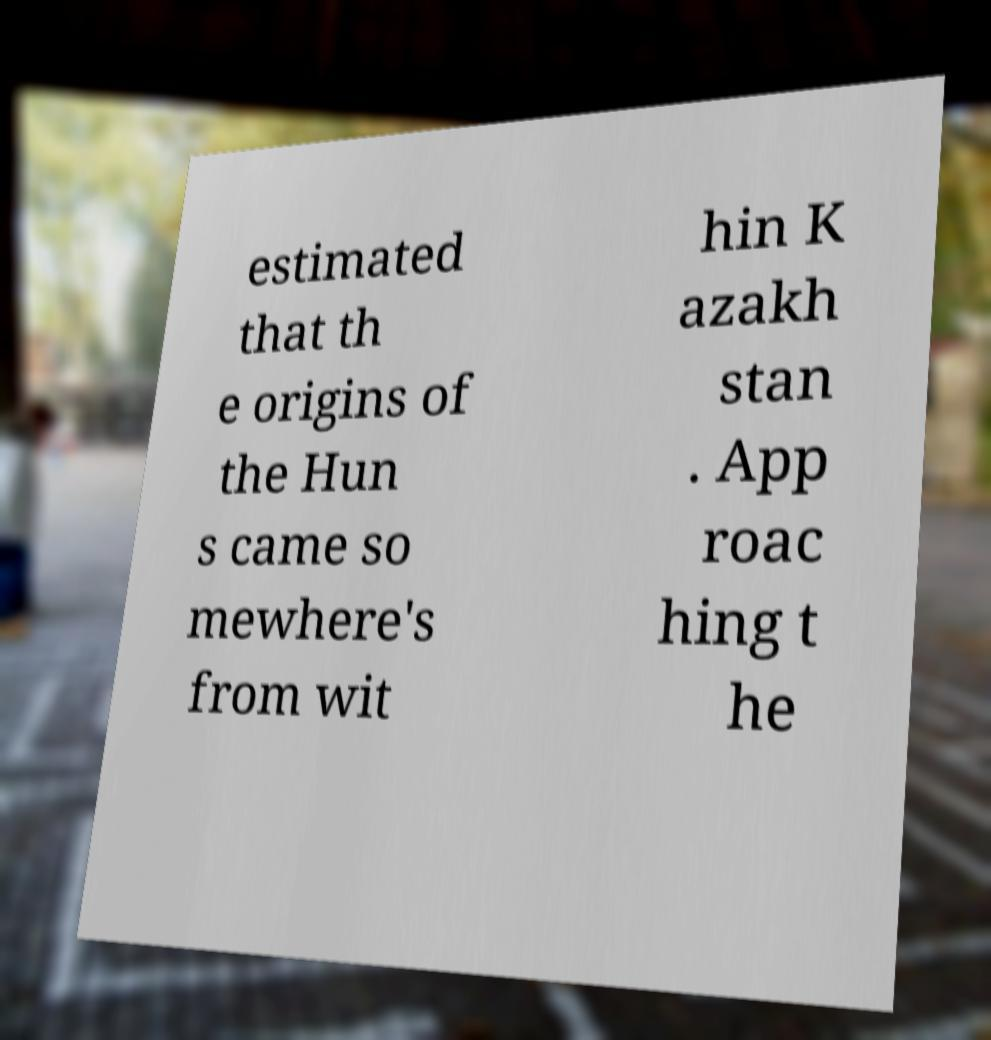There's text embedded in this image that I need extracted. Can you transcribe it verbatim? estimated that th e origins of the Hun s came so mewhere's from wit hin K azakh stan . App roac hing t he 